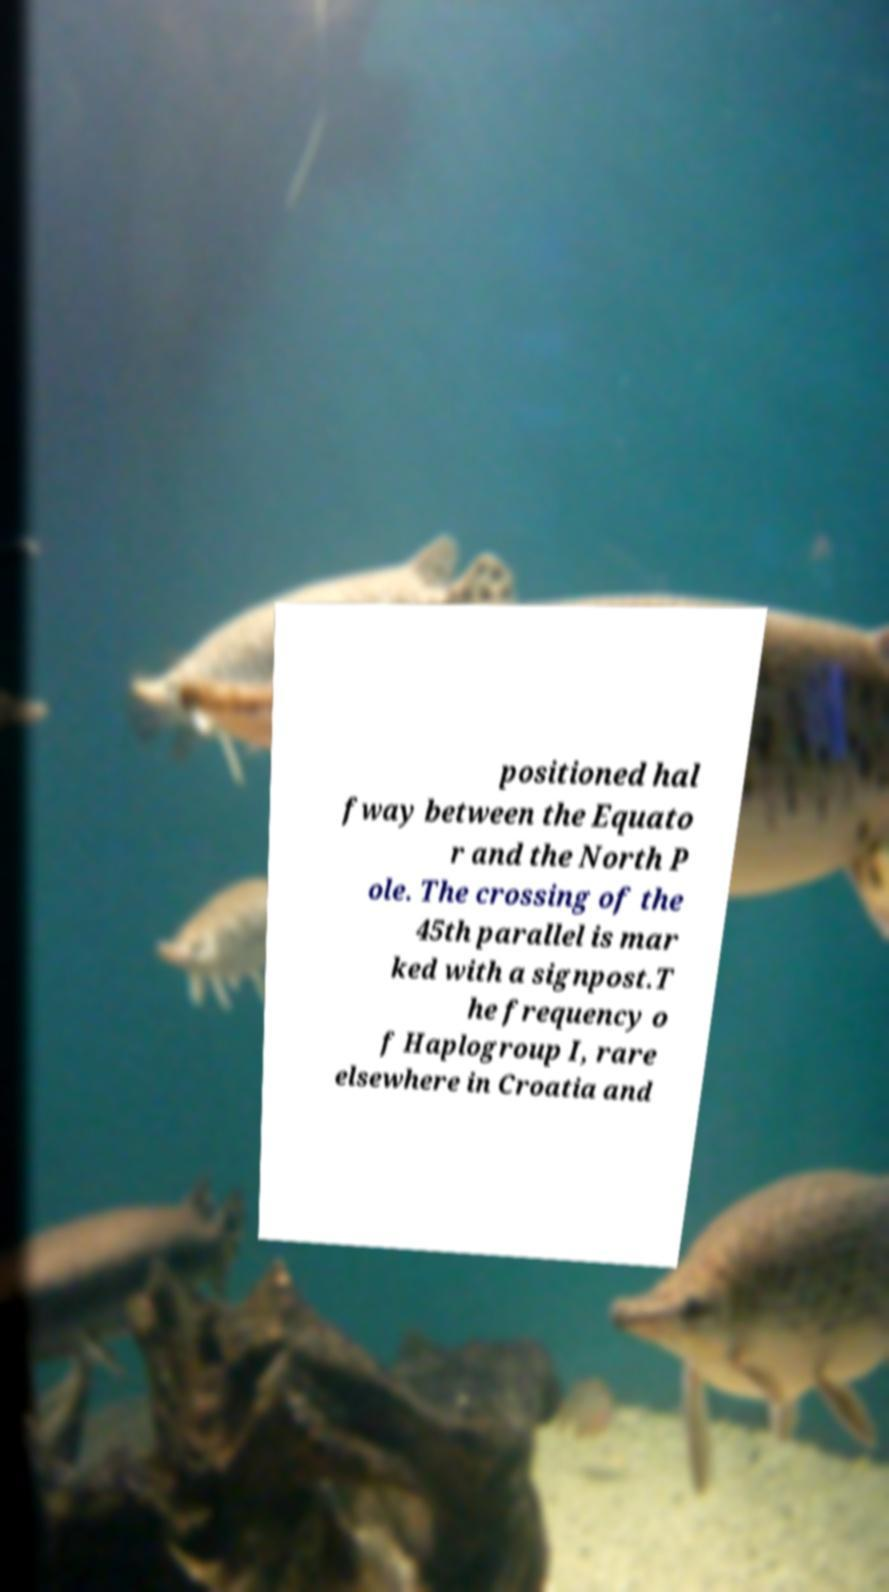Could you extract and type out the text from this image? positioned hal fway between the Equato r and the North P ole. The crossing of the 45th parallel is mar ked with a signpost.T he frequency o f Haplogroup I, rare elsewhere in Croatia and 